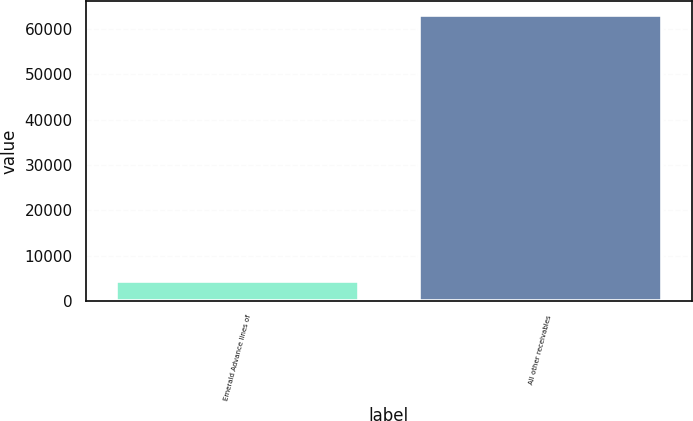Convert chart. <chart><loc_0><loc_0><loc_500><loc_500><bar_chart><fcel>Emerald Advance lines of<fcel>All other receivables<nl><fcel>4400<fcel>63066<nl></chart> 